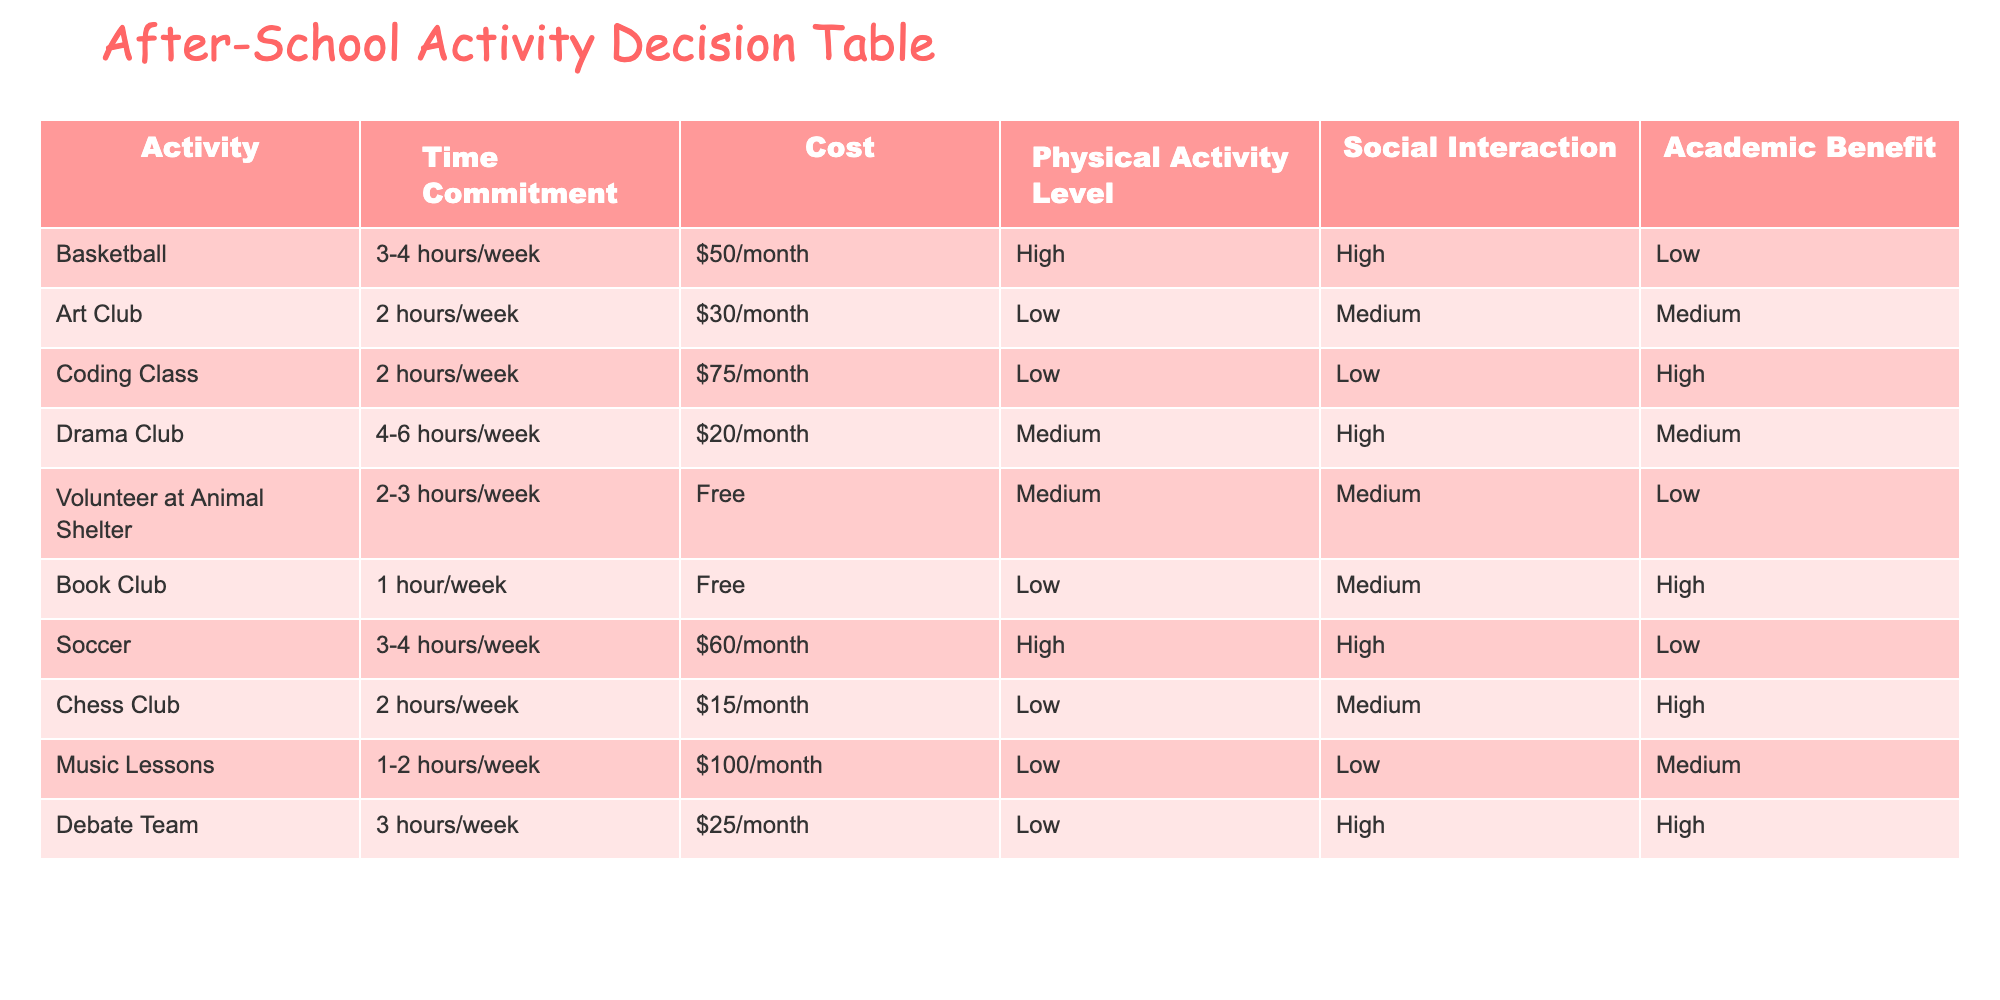What activity has the highest physical activity level? To answer this, we look at the "Physical Activity Level" column. The options with "High" in this column are Basketball, Soccer, and Drama Club. However, Basketball and Soccer both have "High" and the same time commitment hours (3-4 hours/week). Since the question asks for the activity with the highest physical level in terms of commitment, we can consider either Basketball or Soccer as correct responses.
Answer: Basketball or Soccer How many hours per week does the Drama Club require? Directly looking at the "Time Commitment" for the Drama Club, it states 4-6 hours/week. This is a straightforward retrieval of information.
Answer: 4-6 hours/week Is the cost of joining the Chess Club less than the Debate Team? The cost for the Chess Club is $15/month and for the Debate Team is $25/month. Since $15 is less than $25, we can conclude that the statement is true.
Answer: Yes What is the average cost of the after-school activities? First, we need the costs: $50, $30, $75, $20, $0, $0, $60, $15, $100, and $25. Next, we sum the costs: $50 + $30 + $75 + $20 + $0 + $0 + $60 + $15 + $100 + $25 = $375. There are 10 activities, so we find the average by dividing the total cost by the number of activities: $375 / 10 = $37.50.
Answer: $37.50 Which activity offers the highest academic benefit? Looking at the "Academic Benefit" column, the activities that have "High" in that category are Coding Class, Book Club, Debate Team. Since we focus on the highest value, all three can be considered.
Answer: Coding Class, Book Club, or Debate Team Does the Animal Shelter Volunteer position provide any cost? The table indicates that the cost for volunteering at the Animal Shelter is "Free". This directly answers whether there is a cost associated with it.
Answer: No 